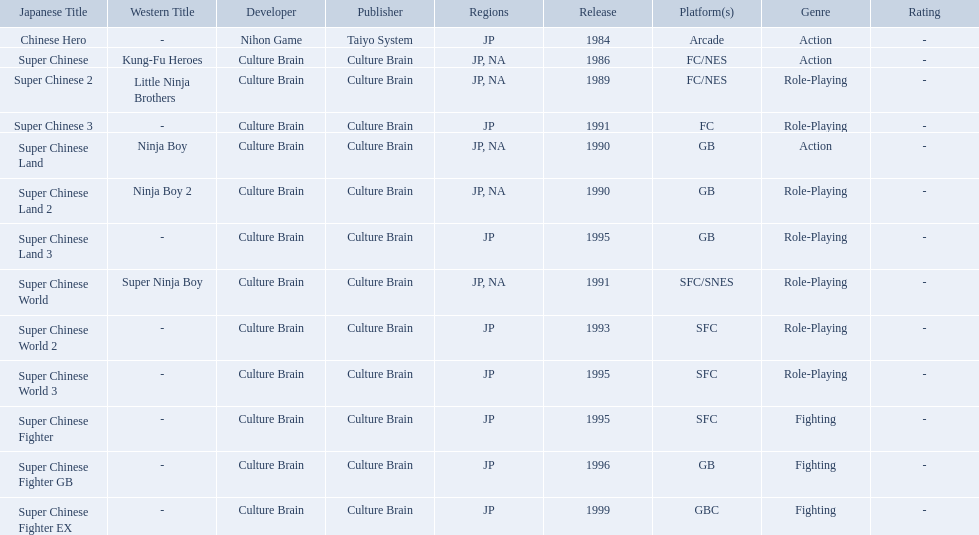Super ninja world was released in what countries? JP, NA. What was the original name for this title? Super Chinese World. Which titles were released in north america? Super Chinese, Super Chinese 2, Super Chinese Land, Super Chinese Land 2, Super Chinese World. Of those, which had the least releases? Super Chinese World. Would you be able to parse every entry in this table? {'header': ['Japanese Title', 'Western Title', 'Developer', 'Publisher', 'Regions', 'Release', 'Platform(s)', 'Genre', 'Rating'], 'rows': [['Chinese Hero', '-', 'Nihon Game', 'Taiyo System', 'JP', '1984', 'Arcade', 'Action', '-'], ['Super Chinese', 'Kung-Fu Heroes', 'Culture Brain', 'Culture Brain', 'JP, NA', '1986', 'FC/NES', 'Action', '-'], ['Super Chinese 2', 'Little Ninja Brothers', 'Culture Brain', 'Culture Brain', 'JP, NA', '1989', 'FC/NES', 'Role-Playing', '-'], ['Super Chinese 3', '-', 'Culture Brain', 'Culture Brain', 'JP', '1991', 'FC', 'Role-Playing', '-'], ['Super Chinese Land', 'Ninja Boy', 'Culture Brain', 'Culture Brain', 'JP, NA', '1990', 'GB', 'Action', '-'], ['Super Chinese Land 2', 'Ninja Boy 2', 'Culture Brain', 'Culture Brain', 'JP, NA', '1990', 'GB', 'Role-Playing', '-'], ['Super Chinese Land 3', '-', 'Culture Brain', 'Culture Brain', 'JP', '1995', 'GB', 'Role-Playing', '-'], ['Super Chinese World', 'Super Ninja Boy', 'Culture Brain', 'Culture Brain', 'JP, NA', '1991', 'SFC/SNES', 'Role-Playing', '-'], ['Super Chinese World 2', '-', 'Culture Brain', 'Culture Brain', 'JP', '1993', 'SFC', 'Role-Playing', '-'], ['Super Chinese World 3', '-', 'Culture Brain', 'Culture Brain', 'JP', '1995', 'SFC', 'Role-Playing', '-'], ['Super Chinese Fighter', '-', 'Culture Brain', 'Culture Brain', 'JP', '1995', 'SFC', 'Fighting', '-'], ['Super Chinese Fighter GB', '-', 'Culture Brain', 'Culture Brain', 'JP', '1996', 'GB', 'Fighting', '-'], ['Super Chinese Fighter EX', '-', 'Culture Brain', 'Culture Brain', 'JP', '1999', 'GBC', 'Fighting', '-']]} What japanese titles were released in the north american (na) region? Super Chinese, Super Chinese 2, Super Chinese Land, Super Chinese Land 2, Super Chinese World. Of those, which one was released most recently? Super Chinese World. 